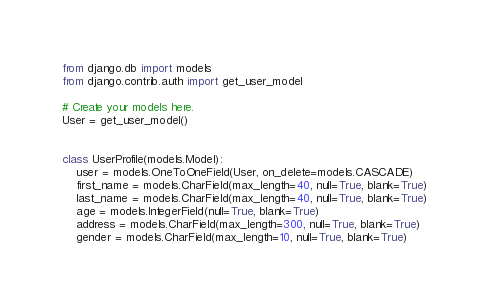Convert code to text. <code><loc_0><loc_0><loc_500><loc_500><_Python_>from django.db import models
from django.contrib.auth import get_user_model

# Create your models here.
User = get_user_model()


class UserProfile(models.Model):
    user = models.OneToOneField(User, on_delete=models.CASCADE)
    first_name = models.CharField(max_length=40, null=True, blank=True)
    last_name = models.CharField(max_length=40, null=True, blank=True)
    age = models.IntegerField(null=True, blank=True)
    address = models.CharField(max_length=300, null=True, blank=True)
    gender = models.CharField(max_length=10, null=True, blank=True)
</code> 